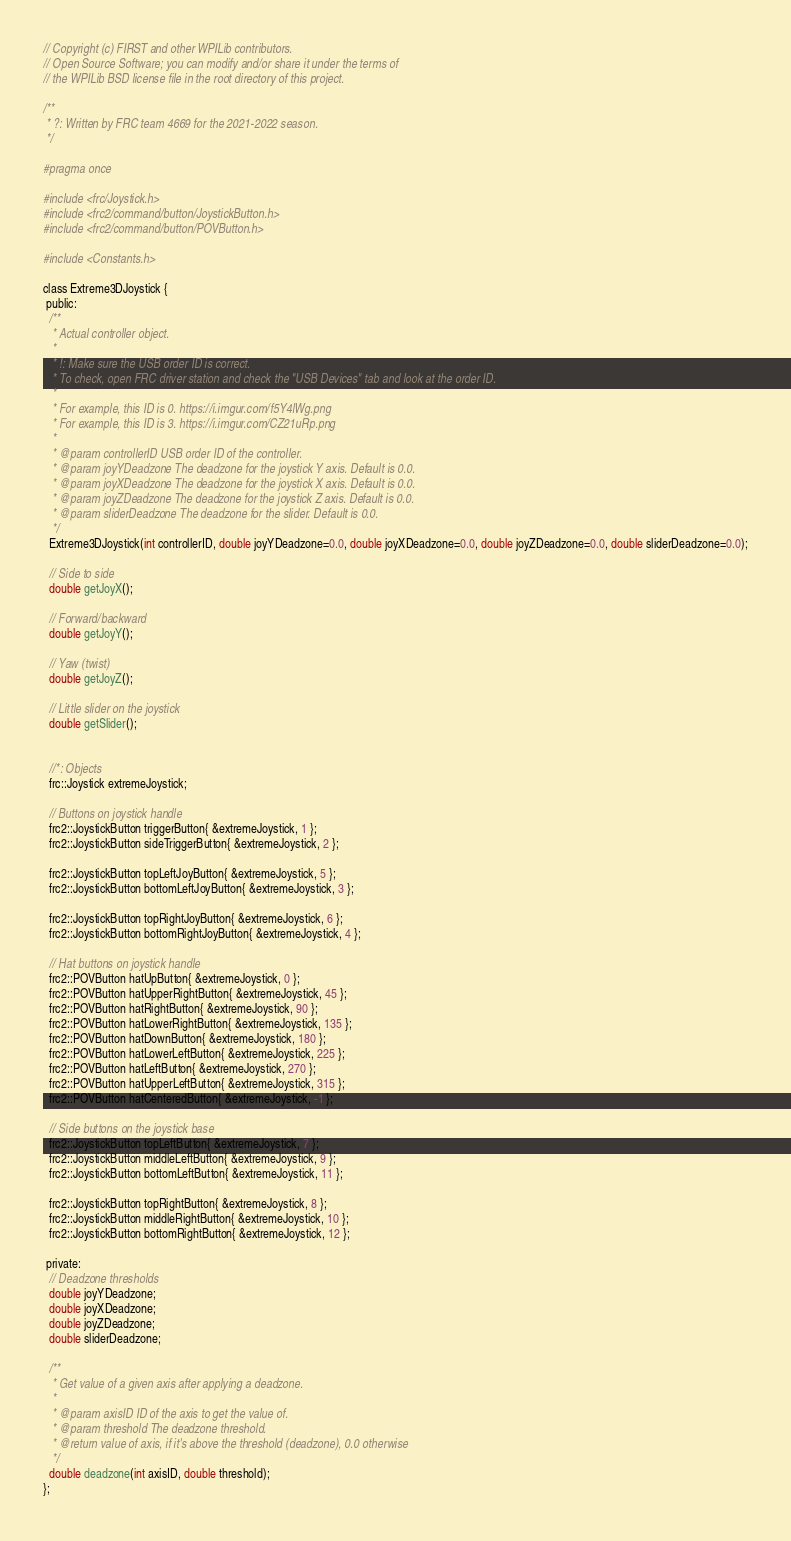<code> <loc_0><loc_0><loc_500><loc_500><_C_>// Copyright (c) FIRST and other WPILib contributors.
// Open Source Software; you can modify and/or share it under the terms of
// the WPILib BSD license file in the root directory of this project.

/**
 * ?: Written by FRC team 4669 for the 2021-2022 season.
 */

#pragma once

#include <frc/Joystick.h>
#include <frc2/command/button/JoystickButton.h>
#include <frc2/command/button/POVButton.h>

#include <Constants.h>

class Extreme3DJoystick {
 public:
  /**
   * Actual controller object.
   *
   * !: Make sure the USB order ID is correct.
   * To check, open FRC driver station and check the "USB Devices" tab and look at the order ID.
   *
   * For example, this ID is 0. https://i.imgur.com/f5Y4lWg.png
   * For example, this ID is 3. https://i.imgur.com/CZ21uRp.png
   *
   * @param controllerID USB order ID of the controller.
   * @param joyYDeadzone The deadzone for the joystick Y axis. Default is 0.0.
   * @param joyXDeadzone The deadzone for the joystick X axis. Default is 0.0.
   * @param joyZDeadzone The deadzone for the joystick Z axis. Default is 0.0.
   * @param sliderDeadzone The deadzone for the slider. Default is 0.0.
   */
  Extreme3DJoystick(int controllerID, double joyYDeadzone=0.0, double joyXDeadzone=0.0, double joyZDeadzone=0.0, double sliderDeadzone=0.0);

  // Side to side
  double getJoyX();

  // Forward/backward
  double getJoyY();

  // Yaw (twist)
  double getJoyZ();

  // Little slider on the joystick
  double getSlider();


  //*: Objects
  frc::Joystick extremeJoystick;

  // Buttons on joystick handle
  frc2::JoystickButton triggerButton{ &extremeJoystick, 1 };
  frc2::JoystickButton sideTriggerButton{ &extremeJoystick, 2 };

  frc2::JoystickButton topLeftJoyButton{ &extremeJoystick, 5 };
  frc2::JoystickButton bottomLeftJoyButton{ &extremeJoystick, 3 };

  frc2::JoystickButton topRightJoyButton{ &extremeJoystick, 6 };
  frc2::JoystickButton bottomRightJoyButton{ &extremeJoystick, 4 };

  // Hat buttons on joystick handle
  frc2::POVButton hatUpButton{ &extremeJoystick, 0 };
  frc2::POVButton hatUpperRightButton{ &extremeJoystick, 45 };
  frc2::POVButton hatRightButton{ &extremeJoystick, 90 };
  frc2::POVButton hatLowerRightButton{ &extremeJoystick, 135 };
  frc2::POVButton hatDownButton{ &extremeJoystick, 180 };
  frc2::POVButton hatLowerLeftButton{ &extremeJoystick, 225 };
  frc2::POVButton hatLeftButton{ &extremeJoystick, 270 };
  frc2::POVButton hatUpperLeftButton{ &extremeJoystick, 315 };
  frc2::POVButton hatCenteredButton{ &extremeJoystick, -1 };

  // Side buttons on the joystick base
  frc2::JoystickButton topLeftButton{ &extremeJoystick, 7 };
  frc2::JoystickButton middleLeftButton{ &extremeJoystick, 9 };
  frc2::JoystickButton bottomLeftButton{ &extremeJoystick, 11 };

  frc2::JoystickButton topRightButton{ &extremeJoystick, 8 };
  frc2::JoystickButton middleRightButton{ &extremeJoystick, 10 };
  frc2::JoystickButton bottomRightButton{ &extremeJoystick, 12 };

 private:
  // Deadzone thresholds
  double joyYDeadzone;
  double joyXDeadzone;
  double joyZDeadzone;
  double sliderDeadzone;

  /**
   * Get value of a given axis after applying a deadzone.
   *
   * @param axisID ID of the axis to get the value of.
   * @param threshold The deadzone threshold.
   * @return value of axis, if it's above the threshold (deadzone), 0.0 otherwise
   */
  double deadzone(int axisID, double threshold);
};
</code> 